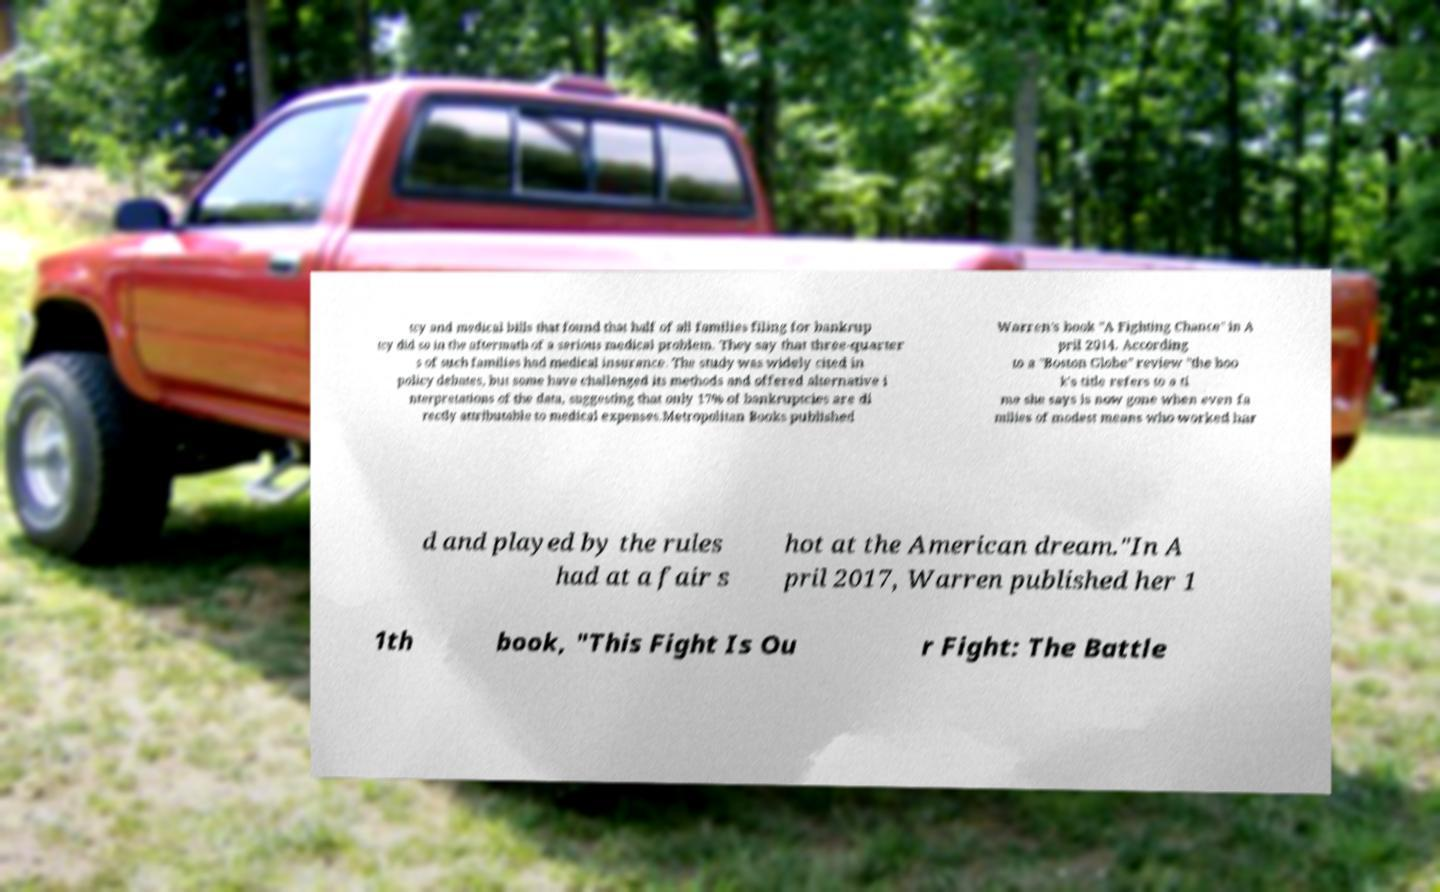Please read and relay the text visible in this image. What does it say? tcy and medical bills that found that half of all families filing for bankrup tcy did so in the aftermath of a serious medical problem. They say that three-quarter s of such families had medical insurance. The study was widely cited in policy debates, but some have challenged its methods and offered alternative i nterpretations of the data, suggesting that only 17% of bankruptcies are di rectly attributable to medical expenses.Metropolitan Books published Warren's book "A Fighting Chance" in A pril 2014. According to a "Boston Globe" review "the boo k's title refers to a ti me she says is now gone when even fa milies of modest means who worked har d and played by the rules had at a fair s hot at the American dream."In A pril 2017, Warren published her 1 1th book, "This Fight Is Ou r Fight: The Battle 